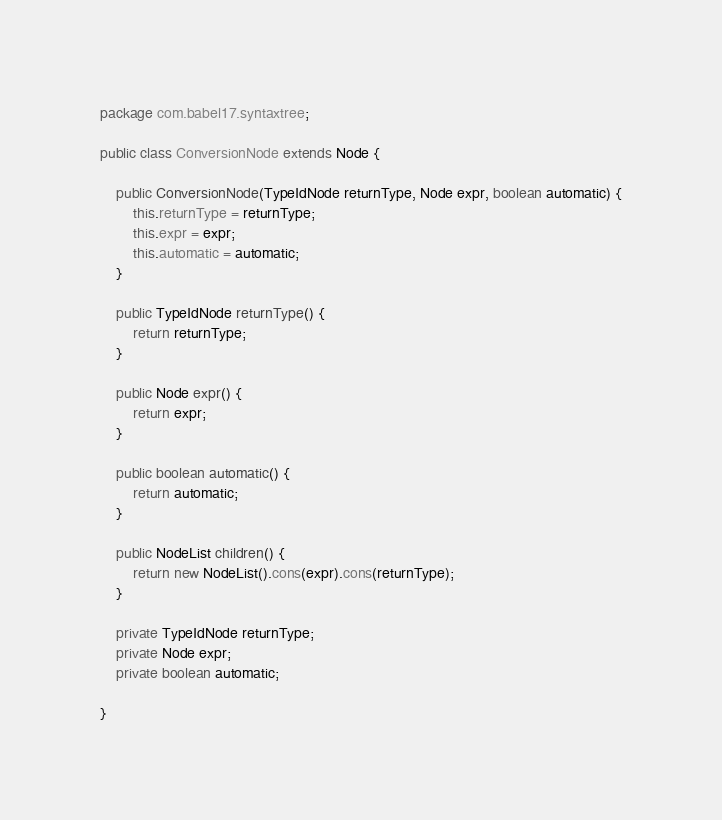Convert code to text. <code><loc_0><loc_0><loc_500><loc_500><_Java_>package com.babel17.syntaxtree;

public class ConversionNode extends Node {

    public ConversionNode(TypeIdNode returnType, Node expr, boolean automatic) {
        this.returnType = returnType;
        this.expr = expr;
        this.automatic = automatic;
    }

    public TypeIdNode returnType() {
        return returnType;
    }

    public Node expr() {
        return expr;
    }
    
    public boolean automatic() {
        return automatic;
    }

    public NodeList children() {
        return new NodeList().cons(expr).cons(returnType);
    }

    private TypeIdNode returnType;
    private Node expr;
    private boolean automatic;

}
</code> 